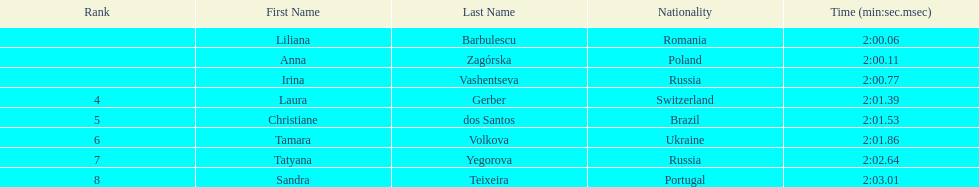Anna zagorska recieved 2nd place, what was her time? 2:00.11. 